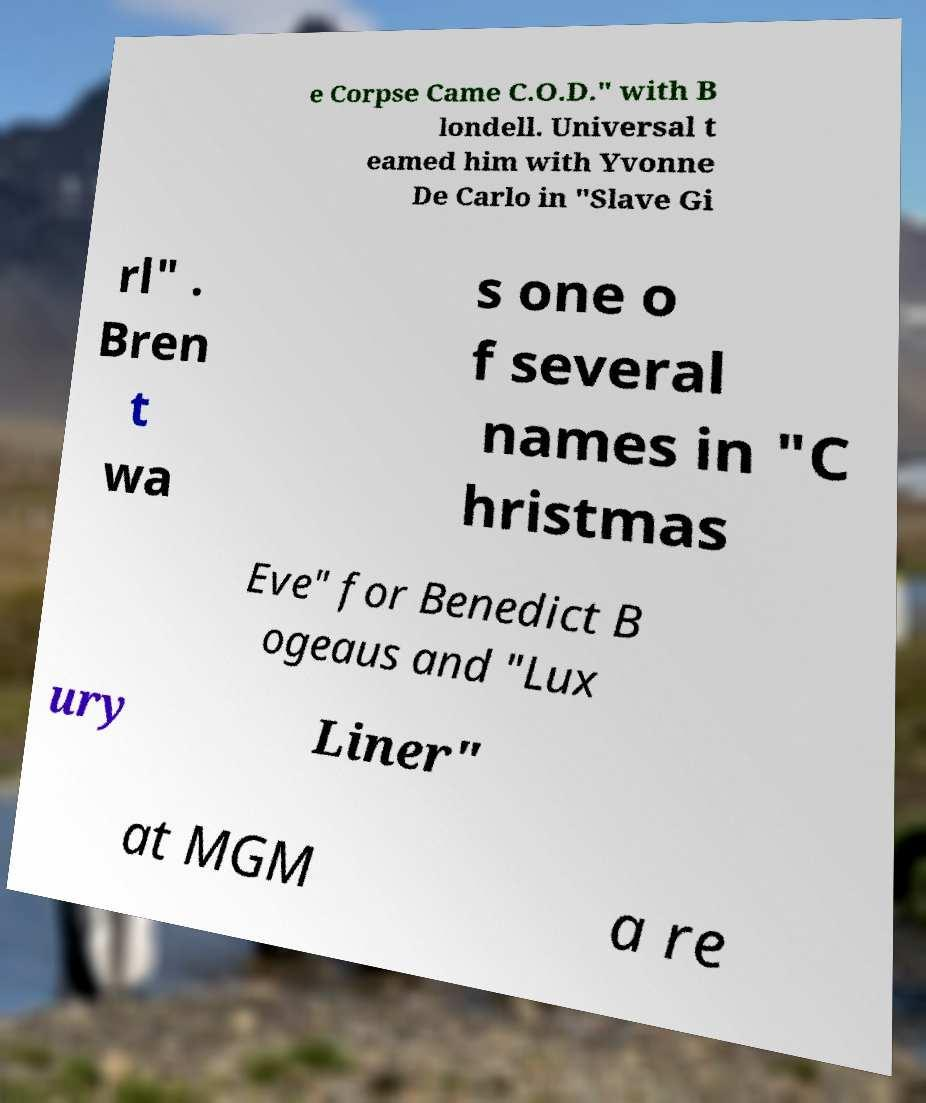For documentation purposes, I need the text within this image transcribed. Could you provide that? e Corpse Came C.O.D." with B londell. Universal t eamed him with Yvonne De Carlo in "Slave Gi rl" . Bren t wa s one o f several names in "C hristmas Eve" for Benedict B ogeaus and "Lux ury Liner" at MGM a re 